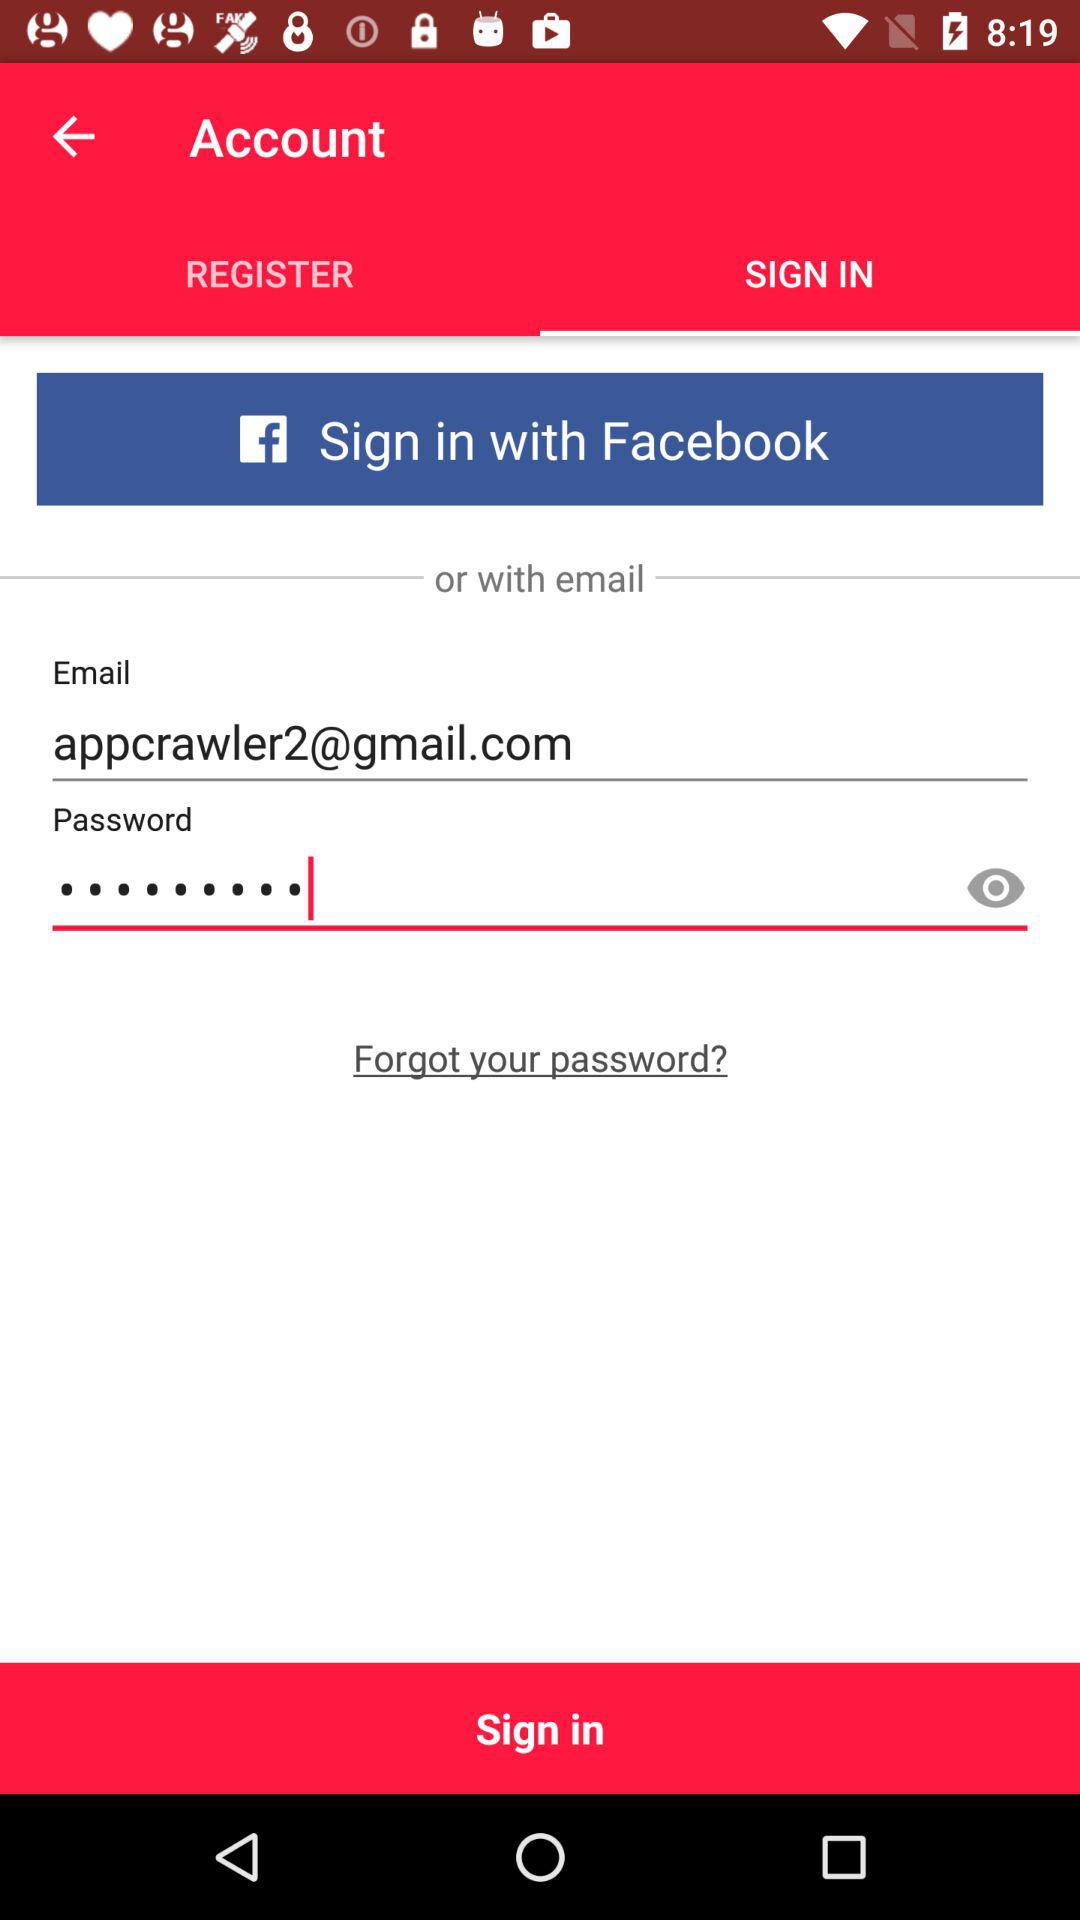What are the different applications through which we can sign in? The application through which you can sign in is "Facebook". 